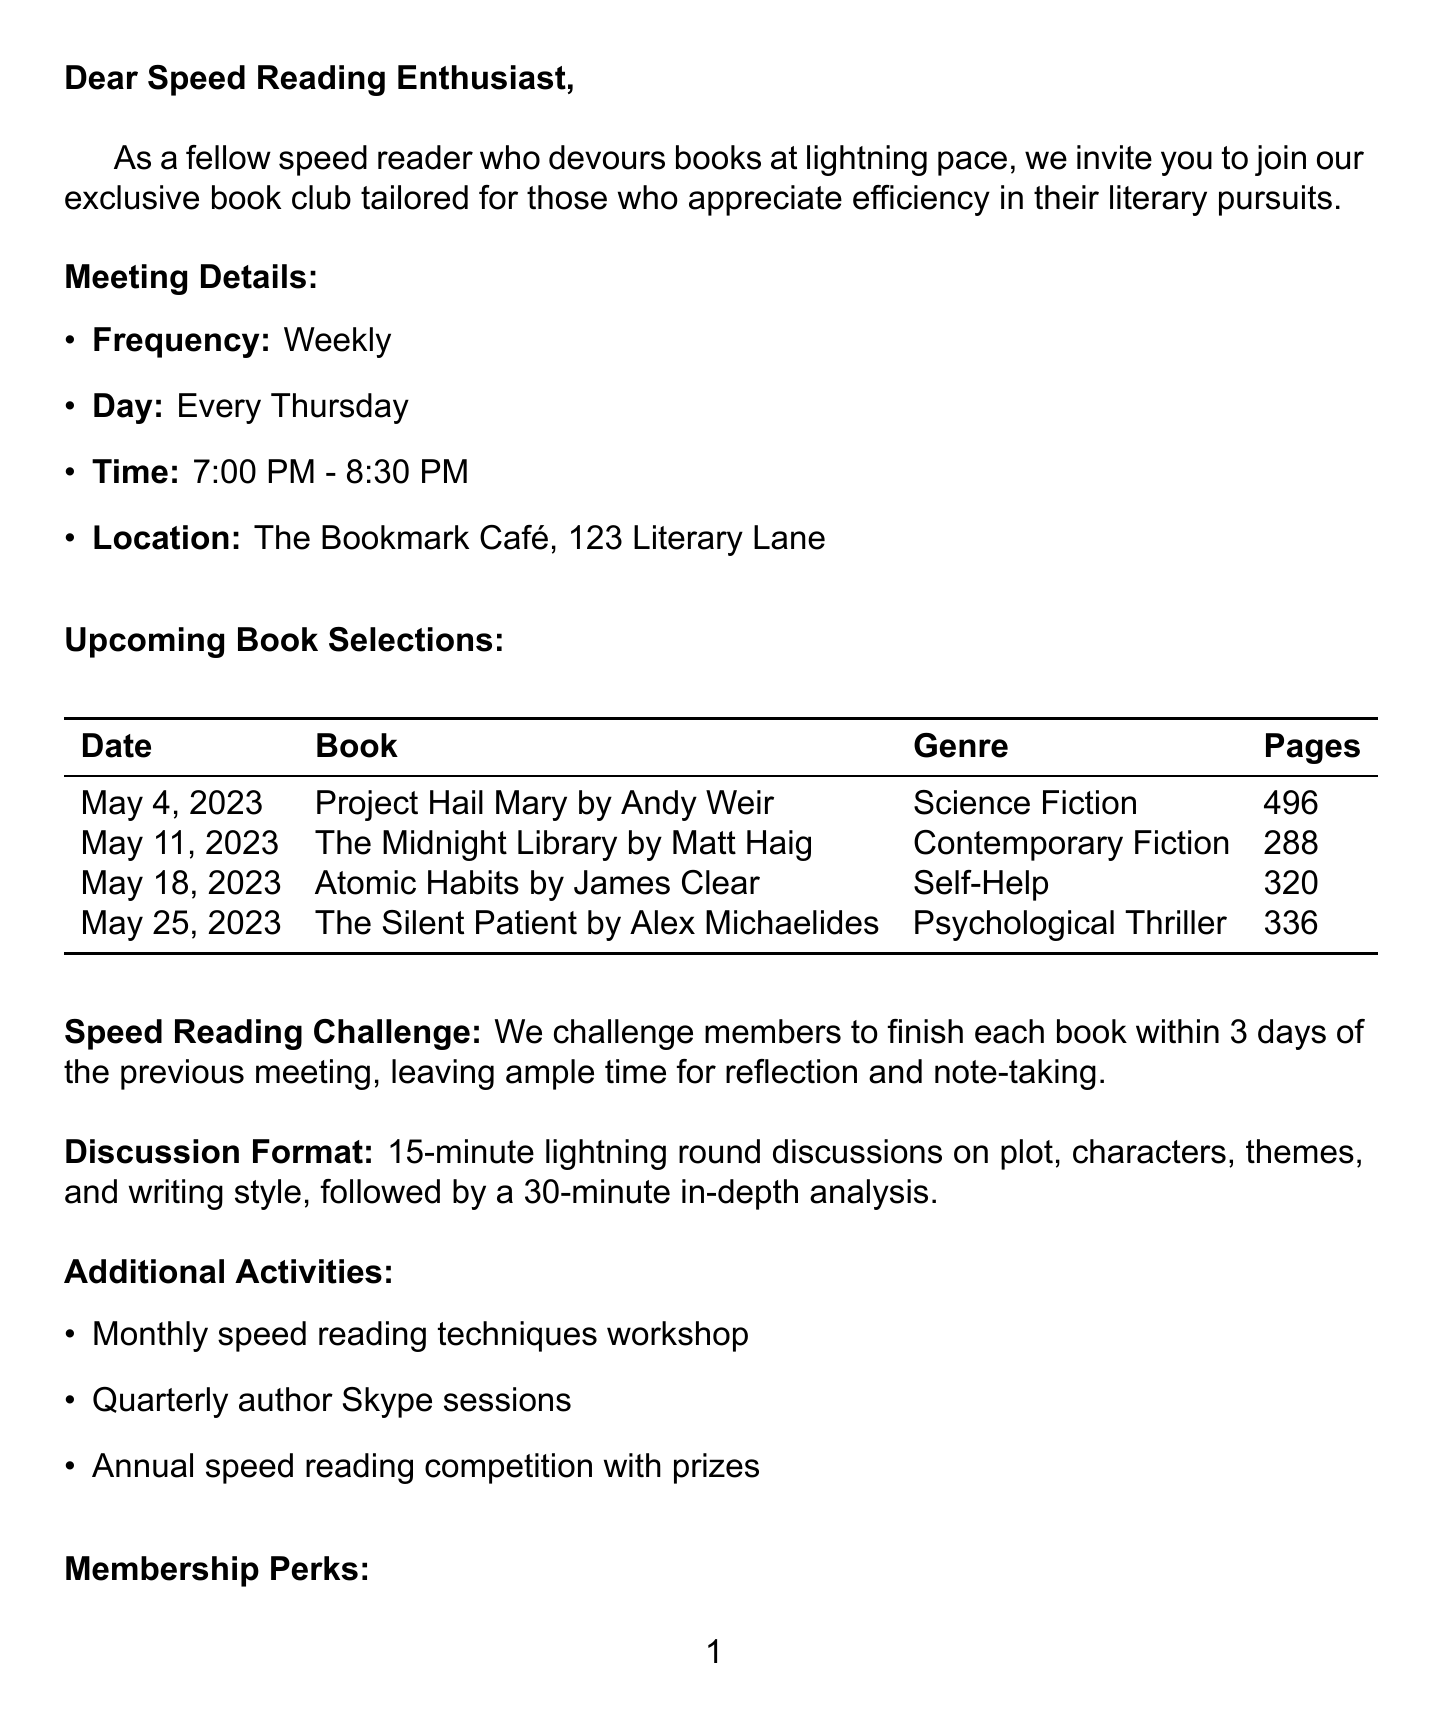What is the name of the book club? The name of the book club is clearly stated in the document as "The Rapid Readers Book Club".
Answer: The Rapid Readers Book Club When is the first meeting scheduled? The first meeting date for the book club is mentioned in the upcoming selections. The first book selection is on May 4, 2023.
Answer: May 4, 2023 How often does the book club meet? The document specifies the frequency of meetings as "Weekly".
Answer: Weekly Who is the contact person for the book club? The contact person's name is provided in the document.
Answer: Emily Swift What is the page count of "Atomic Habits"? The document provides the page count for the book "Atomic Habits" which is part of the upcoming selections.
Answer: 320 What is the primary focus of the monthly speed reading challenge? The challenge requires members to complete each book within a specific timeframe after meetings.
Answer: Finish each book within 3 days What additional activity is mentioned besides the monthly workshops? The document lists various activities, one of which is “Quarterly author Skype sessions”.
Answer: Quarterly author Skype sessions What membership perk involves a discount? The document notes a specific perk related to discounts at a café.
Answer: 10% discount at The Bookmark Café What time do meetings start? The document states the start time for the meetings as part of the meeting details.
Answer: 7:00 PM 